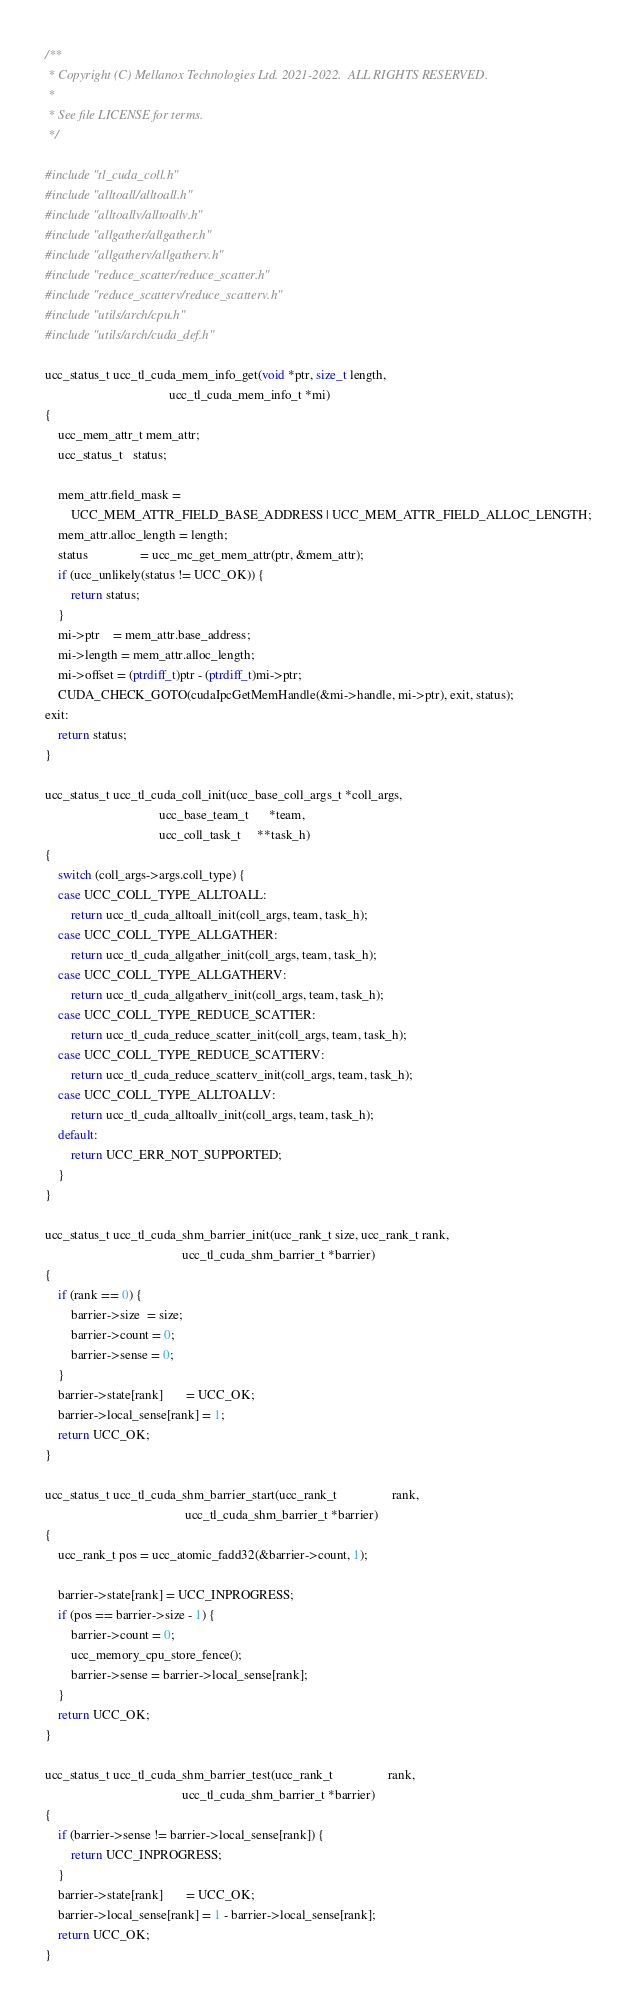<code> <loc_0><loc_0><loc_500><loc_500><_C_>/**
 * Copyright (C) Mellanox Technologies Ltd. 2021-2022.  ALL RIGHTS RESERVED.
 *
 * See file LICENSE for terms.
 */

#include "tl_cuda_coll.h"
#include "alltoall/alltoall.h"
#include "alltoallv/alltoallv.h"
#include "allgather/allgather.h"
#include "allgatherv/allgatherv.h"
#include "reduce_scatter/reduce_scatter.h"
#include "reduce_scatterv/reduce_scatterv.h"
#include "utils/arch/cpu.h"
#include "utils/arch/cuda_def.h"

ucc_status_t ucc_tl_cuda_mem_info_get(void *ptr, size_t length,
                                      ucc_tl_cuda_mem_info_t *mi)
{
    ucc_mem_attr_t mem_attr;
    ucc_status_t   status;

    mem_attr.field_mask =
        UCC_MEM_ATTR_FIELD_BASE_ADDRESS | UCC_MEM_ATTR_FIELD_ALLOC_LENGTH;
    mem_attr.alloc_length = length;
    status                = ucc_mc_get_mem_attr(ptr, &mem_attr);
    if (ucc_unlikely(status != UCC_OK)) {
        return status;
    }
    mi->ptr    = mem_attr.base_address;
    mi->length = mem_attr.alloc_length;
    mi->offset = (ptrdiff_t)ptr - (ptrdiff_t)mi->ptr;
    CUDA_CHECK_GOTO(cudaIpcGetMemHandle(&mi->handle, mi->ptr), exit, status);
exit:
    return status;
}

ucc_status_t ucc_tl_cuda_coll_init(ucc_base_coll_args_t *coll_args,
                                   ucc_base_team_t      *team,
                                   ucc_coll_task_t     **task_h)
{
    switch (coll_args->args.coll_type) {
    case UCC_COLL_TYPE_ALLTOALL:
        return ucc_tl_cuda_alltoall_init(coll_args, team, task_h);
    case UCC_COLL_TYPE_ALLGATHER:
        return ucc_tl_cuda_allgather_init(coll_args, team, task_h);
    case UCC_COLL_TYPE_ALLGATHERV:
        return ucc_tl_cuda_allgatherv_init(coll_args, team, task_h);
    case UCC_COLL_TYPE_REDUCE_SCATTER:
        return ucc_tl_cuda_reduce_scatter_init(coll_args, team, task_h);
    case UCC_COLL_TYPE_REDUCE_SCATTERV:
        return ucc_tl_cuda_reduce_scatterv_init(coll_args, team, task_h);
    case UCC_COLL_TYPE_ALLTOALLV:
        return ucc_tl_cuda_alltoallv_init(coll_args, team, task_h);
    default:
        return UCC_ERR_NOT_SUPPORTED;
    }
}

ucc_status_t ucc_tl_cuda_shm_barrier_init(ucc_rank_t size, ucc_rank_t rank,
                                          ucc_tl_cuda_shm_barrier_t *barrier)
{
    if (rank == 0) {
        barrier->size  = size;
        barrier->count = 0;
        barrier->sense = 0;
    }
    barrier->state[rank]       = UCC_OK;
    barrier->local_sense[rank] = 1;
    return UCC_OK;
}

ucc_status_t ucc_tl_cuda_shm_barrier_start(ucc_rank_t                 rank,
                                           ucc_tl_cuda_shm_barrier_t *barrier)
{
    ucc_rank_t pos = ucc_atomic_fadd32(&barrier->count, 1);

    barrier->state[rank] = UCC_INPROGRESS;
    if (pos == barrier->size - 1) {
        barrier->count = 0;
        ucc_memory_cpu_store_fence();
        barrier->sense = barrier->local_sense[rank];
    }
    return UCC_OK;
}

ucc_status_t ucc_tl_cuda_shm_barrier_test(ucc_rank_t                 rank,
                                          ucc_tl_cuda_shm_barrier_t *barrier)
{
    if (barrier->sense != barrier->local_sense[rank]) {
        return UCC_INPROGRESS;
    }
    barrier->state[rank]       = UCC_OK;
    barrier->local_sense[rank] = 1 - barrier->local_sense[rank];
    return UCC_OK;
}
</code> 